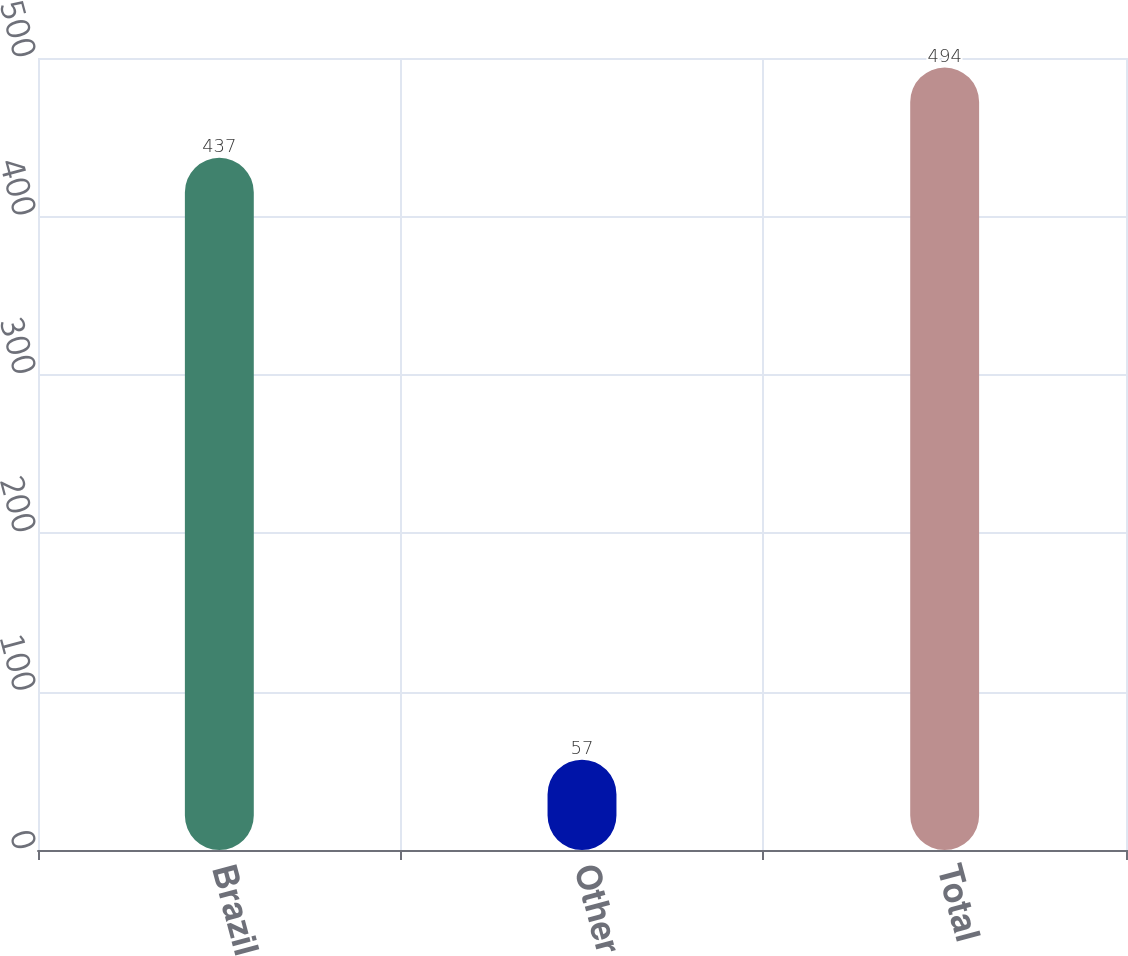Convert chart. <chart><loc_0><loc_0><loc_500><loc_500><bar_chart><fcel>Brazil<fcel>Other<fcel>Total<nl><fcel>437<fcel>57<fcel>494<nl></chart> 